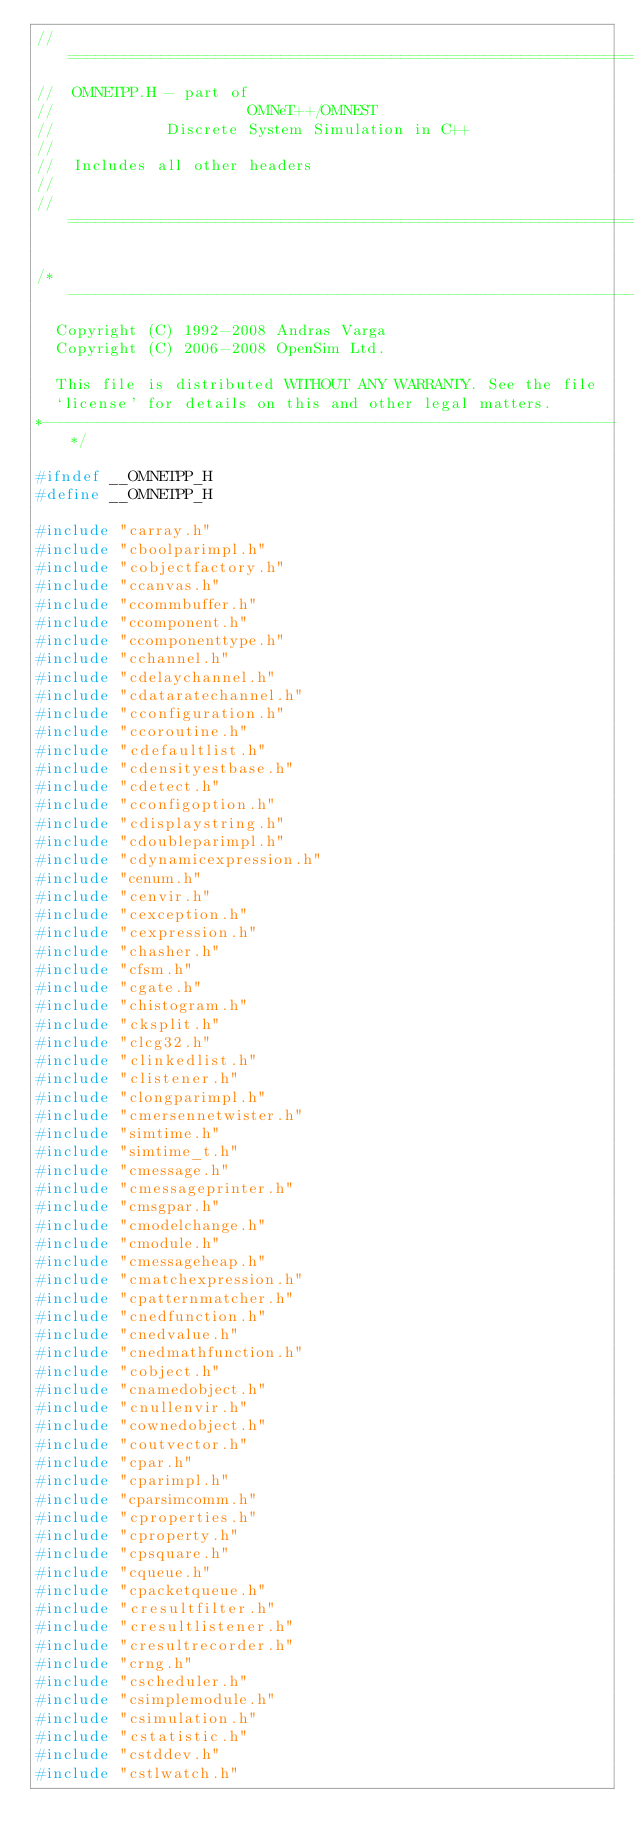Convert code to text. <code><loc_0><loc_0><loc_500><loc_500><_C_>//==========================================================================
//  OMNETPP.H - part of
//                     OMNeT++/OMNEST
//            Discrete System Simulation in C++
//
//  Includes all other headers
//
//==========================================================================

/*--------------------------------------------------------------*
  Copyright (C) 1992-2008 Andras Varga
  Copyright (C) 2006-2008 OpenSim Ltd.

  This file is distributed WITHOUT ANY WARRANTY. See the file
  `license' for details on this and other legal matters.
*--------------------------------------------------------------*/

#ifndef __OMNETPP_H
#define __OMNETPP_H

#include "carray.h"
#include "cboolparimpl.h"
#include "cobjectfactory.h"
#include "ccanvas.h"
#include "ccommbuffer.h"
#include "ccomponent.h"
#include "ccomponenttype.h"
#include "cchannel.h"
#include "cdelaychannel.h"
#include "cdataratechannel.h"
#include "cconfiguration.h"
#include "ccoroutine.h"
#include "cdefaultlist.h"
#include "cdensityestbase.h"
#include "cdetect.h"
#include "cconfigoption.h"
#include "cdisplaystring.h"
#include "cdoubleparimpl.h"
#include "cdynamicexpression.h"
#include "cenum.h"
#include "cenvir.h"
#include "cexception.h"
#include "cexpression.h"
#include "chasher.h"
#include "cfsm.h"
#include "cgate.h"
#include "chistogram.h"
#include "cksplit.h"
#include "clcg32.h"
#include "clinkedlist.h"
#include "clistener.h"
#include "clongparimpl.h"
#include "cmersennetwister.h"
#include "simtime.h"
#include "simtime_t.h"
#include "cmessage.h"
#include "cmessageprinter.h"
#include "cmsgpar.h"
#include "cmodelchange.h"
#include "cmodule.h"
#include "cmessageheap.h"
#include "cmatchexpression.h"
#include "cpatternmatcher.h"
#include "cnedfunction.h"
#include "cnedvalue.h"
#include "cnedmathfunction.h"
#include "cobject.h"
#include "cnamedobject.h"
#include "cnullenvir.h"
#include "cownedobject.h"
#include "coutvector.h"
#include "cpar.h"
#include "cparimpl.h"
#include "cparsimcomm.h"
#include "cproperties.h"
#include "cproperty.h"
#include "cpsquare.h"
#include "cqueue.h"
#include "cpacketqueue.h"
#include "cresultfilter.h"
#include "cresultlistener.h"
#include "cresultrecorder.h"
#include "crng.h"
#include "cscheduler.h"
#include "csimplemodule.h"
#include "csimulation.h"
#include "cstatistic.h"
#include "cstddev.h"
#include "cstlwatch.h"</code> 